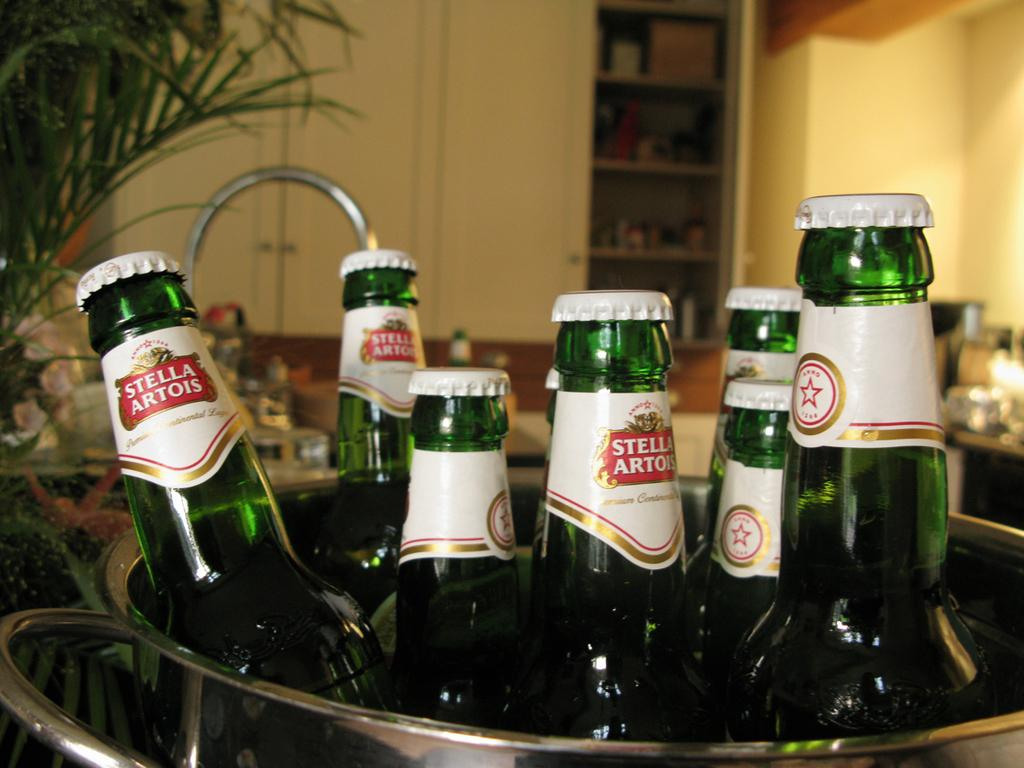What objects are in the bowl in the image? There are bottles in a bowl in the image. What can be seen in the background of the image? There is a wall in the background of the image. What structure is present in the image? There is a rack in the image. What type of thread is being used to hang the advertisement on the wall in the image? There is no advertisement present in the image, so there is no thread being used to hang it. 